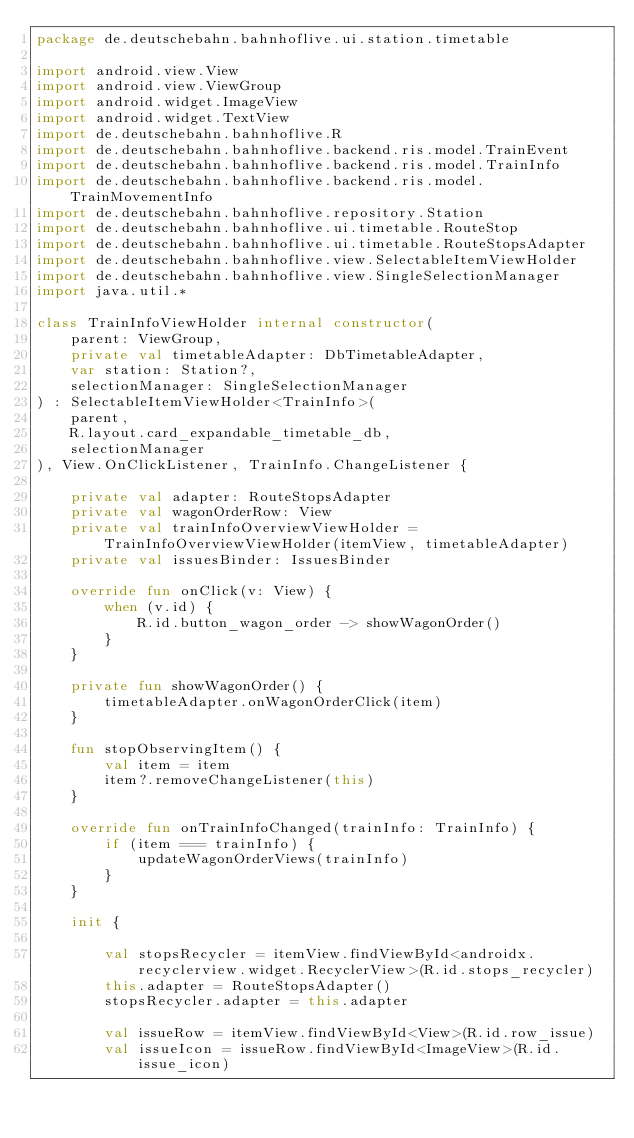<code> <loc_0><loc_0><loc_500><loc_500><_Kotlin_>package de.deutschebahn.bahnhoflive.ui.station.timetable

import android.view.View
import android.view.ViewGroup
import android.widget.ImageView
import android.widget.TextView
import de.deutschebahn.bahnhoflive.R
import de.deutschebahn.bahnhoflive.backend.ris.model.TrainEvent
import de.deutschebahn.bahnhoflive.backend.ris.model.TrainInfo
import de.deutschebahn.bahnhoflive.backend.ris.model.TrainMovementInfo
import de.deutschebahn.bahnhoflive.repository.Station
import de.deutschebahn.bahnhoflive.ui.timetable.RouteStop
import de.deutschebahn.bahnhoflive.ui.timetable.RouteStopsAdapter
import de.deutschebahn.bahnhoflive.view.SelectableItemViewHolder
import de.deutschebahn.bahnhoflive.view.SingleSelectionManager
import java.util.*

class TrainInfoViewHolder internal constructor(
    parent: ViewGroup,
    private val timetableAdapter: DbTimetableAdapter,
    var station: Station?,
    selectionManager: SingleSelectionManager
) : SelectableItemViewHolder<TrainInfo>(
    parent,
    R.layout.card_expandable_timetable_db,
    selectionManager
), View.OnClickListener, TrainInfo.ChangeListener {

    private val adapter: RouteStopsAdapter
    private val wagonOrderRow: View
    private val trainInfoOverviewViewHolder = TrainInfoOverviewViewHolder(itemView, timetableAdapter)
    private val issuesBinder: IssuesBinder

    override fun onClick(v: View) {
        when (v.id) {
            R.id.button_wagon_order -> showWagonOrder()
        }
    }

    private fun showWagonOrder() {
        timetableAdapter.onWagonOrderClick(item)
    }

    fun stopObservingItem() {
        val item = item
        item?.removeChangeListener(this)
    }

    override fun onTrainInfoChanged(trainInfo: TrainInfo) {
        if (item === trainInfo) {
            updateWagonOrderViews(trainInfo)
        }
    }

    init {

        val stopsRecycler = itemView.findViewById<androidx.recyclerview.widget.RecyclerView>(R.id.stops_recycler)
        this.adapter = RouteStopsAdapter()
        stopsRecycler.adapter = this.adapter

        val issueRow = itemView.findViewById<View>(R.id.row_issue)
        val issueIcon = issueRow.findViewById<ImageView>(R.id.issue_icon)</code> 